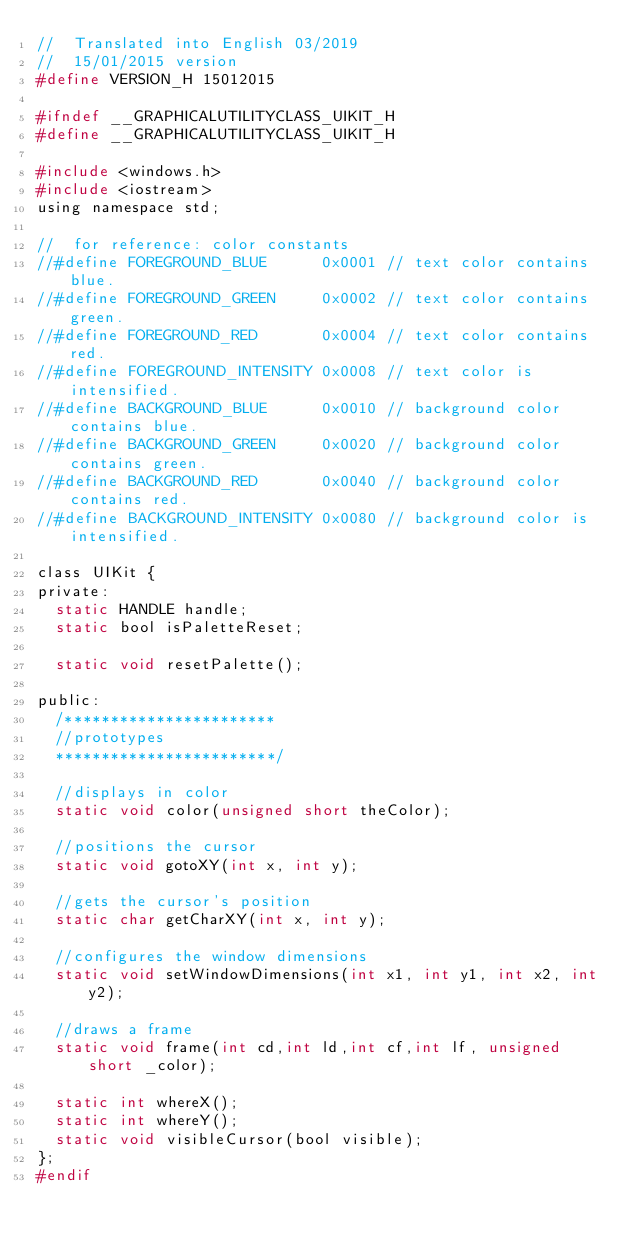<code> <loc_0><loc_0><loc_500><loc_500><_C_>//  Translated into English 03/2019
//	15/01/2015 version
#define VERSION_H 15012015

#ifndef __GRAPHICALUTILITYCLASS_UIKIT_H
#define __GRAPHICALUTILITYCLASS_UIKIT_H

#include <windows.h>
#include <iostream>
using namespace std;

//	for reference: color constants
//#define FOREGROUND_BLUE      0x0001 // text color contains blue.
//#define FOREGROUND_GREEN     0x0002 // text color contains green.
//#define FOREGROUND_RED       0x0004 // text color contains red.
//#define FOREGROUND_INTENSITY 0x0008 // text color is intensified.
//#define BACKGROUND_BLUE      0x0010 // background color contains blue.
//#define BACKGROUND_GREEN     0x0020 // background color contains green.
//#define BACKGROUND_RED       0x0040 // background color contains red.
//#define BACKGROUND_INTENSITY 0x0080 // background color is intensified.

class UIKit {
private:
	static HANDLE handle;
	static bool isPaletteReset;

	static void resetPalette();

public:
	/***********************
	//prototypes
	************************/

	//displays in color
	static void color(unsigned short theColor);

	//positions the cursor
	static void gotoXY(int x, int y);

	//gets the cursor's position
	static char getCharXY(int x, int y);

	//configures the window dimensions
	static void setWindowDimensions(int x1, int y1, int x2, int y2);

	//draws a frame
	static void frame(int cd,int ld,int cf,int lf, unsigned short _color);

	static int whereX();
	static int whereY();
	static void visibleCursor(bool visible);
};
#endif
</code> 